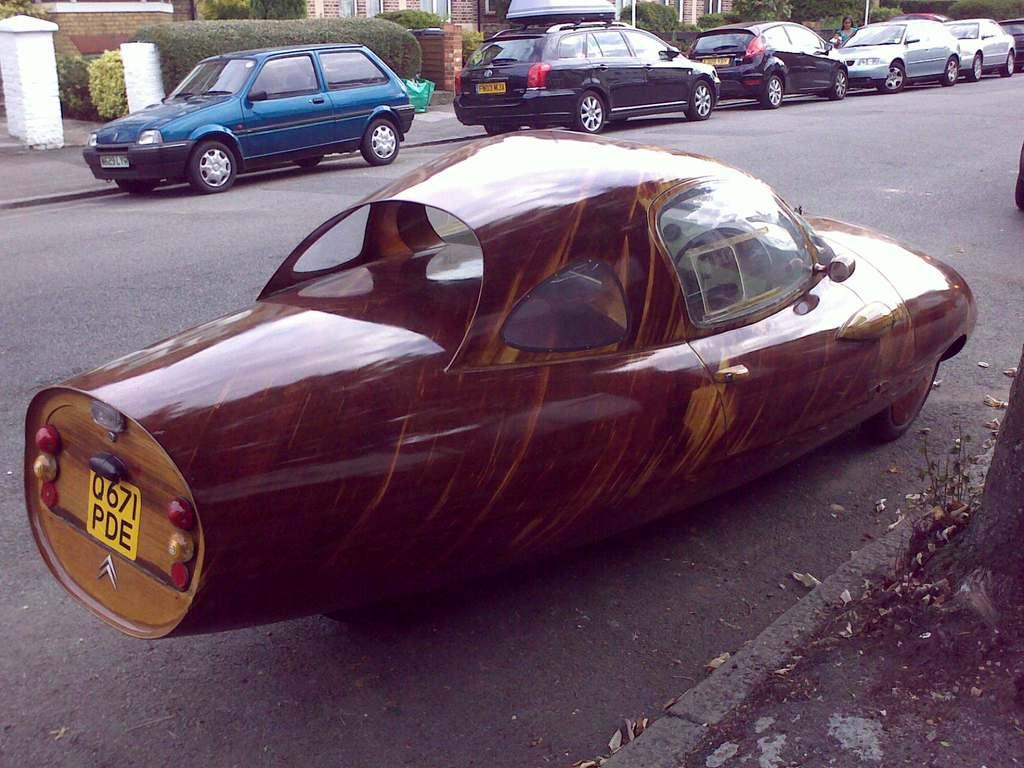What is the main subject in the center of the image? There is a car in the center of the image. Where is the car located? The car is on the road. What can be seen in the background of the image? There are cars, buildings, trees, and plants visible in the background of the image. What type of oatmeal is being served in the car in the image? There is no oatmeal present in the image; it features a car on the road with a background of other cars, buildings, trees, and plants. 